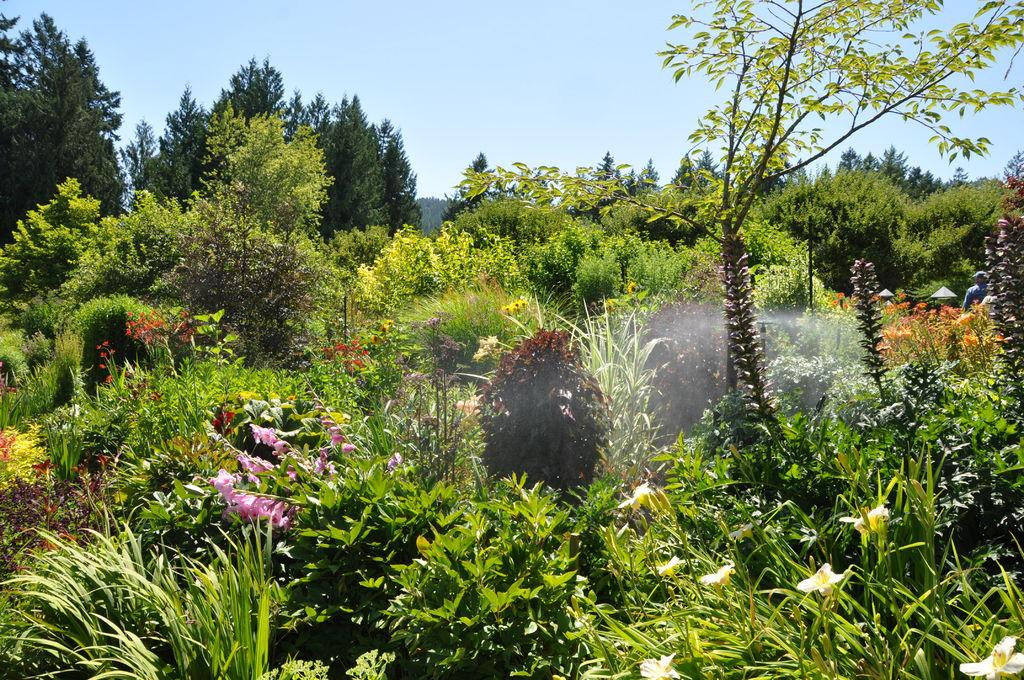What type of vegetation can be seen in the image? There is grass, flowering plants, and trees in the image. What part of the natural environment is visible in the image? The sky is visible at the top of the image. How much money is being exchanged in the image? There is no mention of money or any exchange in the image; it features grass, flowering plants, trees, and the sky. 